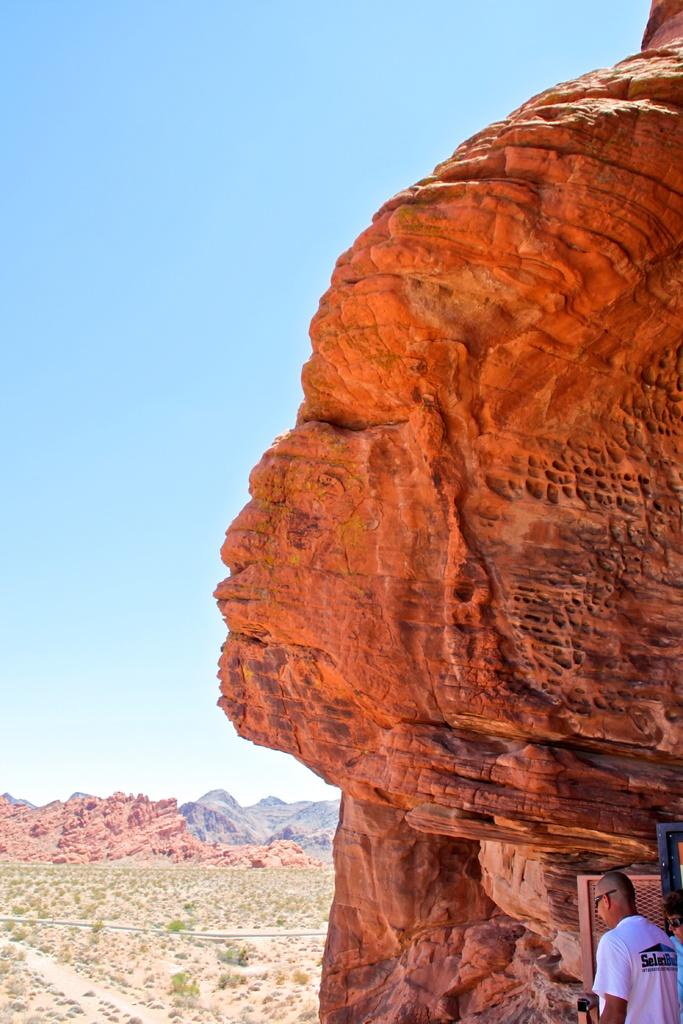What can be seen on the right side of the image? There is a sculpture on the right side of the image. Who is present in the bottom right side of the image? There is a man in the bottom right side of the image. What type of natural formation is on the left side of the image? There are rocks on the left side of the image. What type of science experiment is being conducted on the shelf in the image? There is no shelf or science experiment present in the image. How many cattle can be seen grazing in the image? There are no cattle present in the image. 